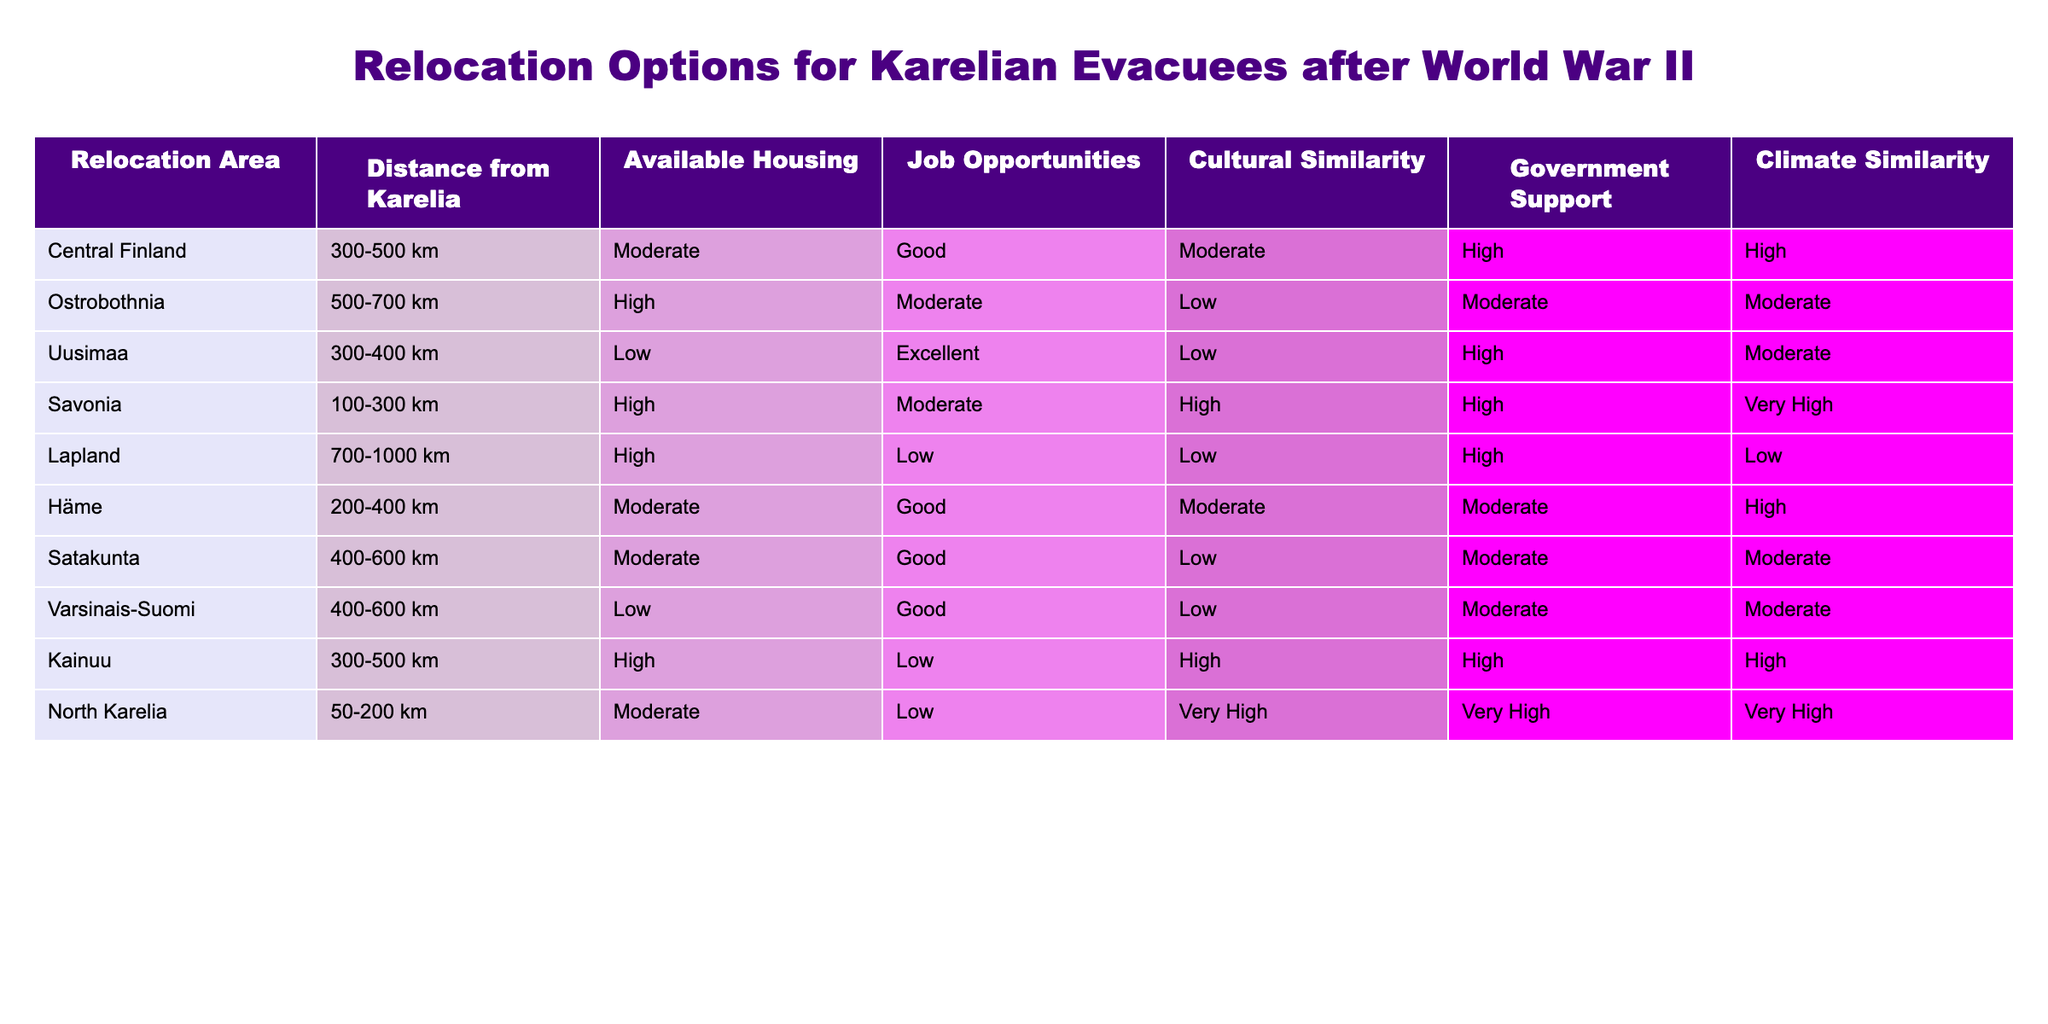What is the distance range of relocation options in Savonia? The table shows that Savonia has a distance range classified as 100-300 km from Karelia.
Answer: 100-300 km Which relocation area has the highest government support? According to the table, both North Karelia and Savonia are listed to have very high government support.
Answer: North Karelia and Savonia How many relocation areas offer good job opportunities? In the table, Central Finland, Uusimaa, Häme, and Satakunta all provide good job opportunities making it a total of 4 areas.
Answer: 4 areas Is the cultural similarity in Kainuu low? The table indicates that Kainuu has high cultural similarity, so it is not low.
Answer: No Which area has moderate housing availability and very high cultural similarity? The table shows North Karelia has moderate housing availability along with very high cultural similarity.
Answer: North Karelia Calculate the total number of relocation areas that fall within a distance of 300-500 km from Karelia. By examining the table, Central Finland, Kainuu, and Ostrobothnia all fall within the 300-500 km range making a total of 3 areas.
Answer: 3 areas Is Lapland a suitable option for those prioritizing job opportunities? The table shows Lapland has low job opportunities, making it an unsuitable option for that priority.
Answer: No What relocation area has both excellent job opportunities and low housing availability? According to the table, Uusimaa is noted for having excellent job opportunities while housing availability is low.
Answer: Uusimaa 